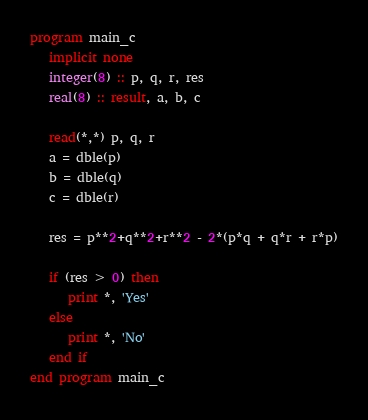<code> <loc_0><loc_0><loc_500><loc_500><_FORTRAN_>program main_c
   implicit none
   integer(8) :: p, q, r, res
   real(8) :: result, a, b, c

   read(*,*) p, q, r
   a = dble(p)
   b = dble(q)
   c = dble(r)

   res = p**2+q**2+r**2 - 2*(p*q + q*r + r*p)

   if (res > 0) then
      print *, 'Yes'
   else
      print *, 'No'
   end if
end program main_c
</code> 